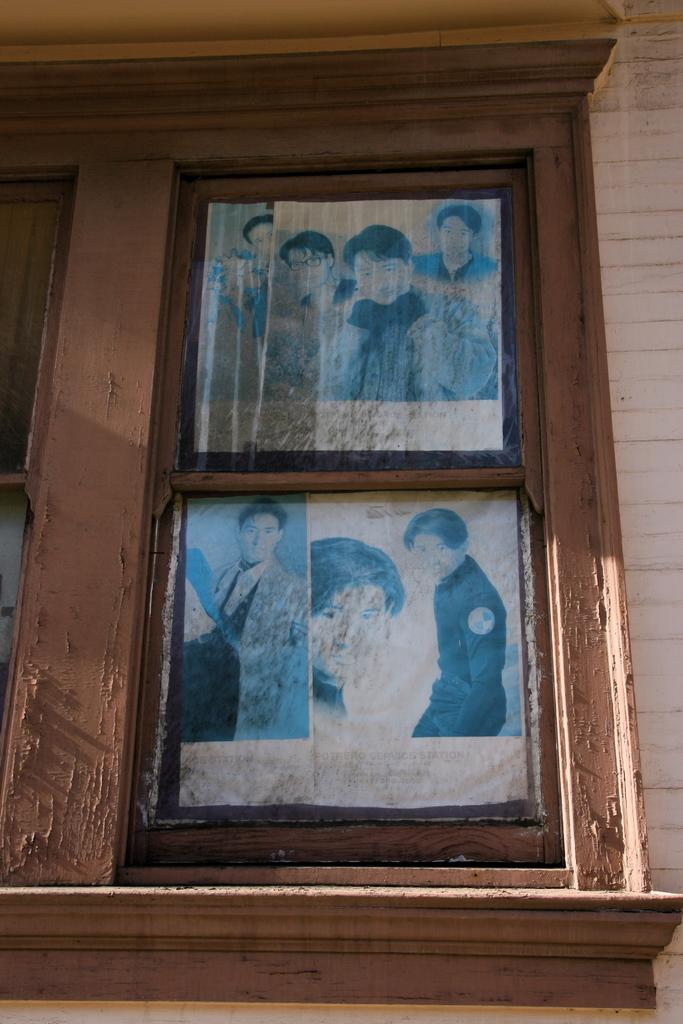How many pictures are present in the image? There are two pictures in the image. Where are the pictures located? The pictures are attached to a window. What type of dinner is being served in the image? There is no dinner present in the image; it only features two pictures attached to a window. 